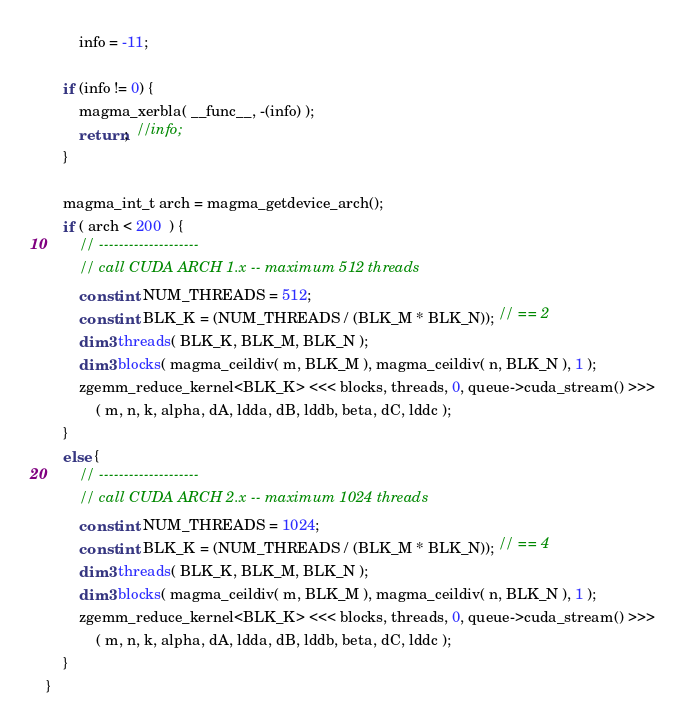Convert code to text. <code><loc_0><loc_0><loc_500><loc_500><_Cuda_>        info = -11;
    
    if (info != 0) {
        magma_xerbla( __func__, -(info) );
        return;  //info;
    }
    
    magma_int_t arch = magma_getdevice_arch();
    if ( arch < 200  ) {
        // --------------------
        // call CUDA ARCH 1.x -- maximum 512 threads
        const int NUM_THREADS = 512;
        const int BLK_K = (NUM_THREADS / (BLK_M * BLK_N)); // == 2
        dim3 threads( BLK_K, BLK_M, BLK_N );
        dim3 blocks( magma_ceildiv( m, BLK_M ), magma_ceildiv( n, BLK_N ), 1 );
        zgemm_reduce_kernel<BLK_K> <<< blocks, threads, 0, queue->cuda_stream() >>>
            ( m, n, k, alpha, dA, ldda, dB, lddb, beta, dC, lddc );
    }
    else {
        // --------------------
        // call CUDA ARCH 2.x -- maximum 1024 threads
        const int NUM_THREADS = 1024;
        const int BLK_K = (NUM_THREADS / (BLK_M * BLK_N)); // == 4
        dim3 threads( BLK_K, BLK_M, BLK_N );
        dim3 blocks( magma_ceildiv( m, BLK_M ), magma_ceildiv( n, BLK_N ), 1 );
        zgemm_reduce_kernel<BLK_K> <<< blocks, threads, 0, queue->cuda_stream() >>>
            ( m, n, k, alpha, dA, ldda, dB, lddb, beta, dC, lddc );
    }
}
</code> 